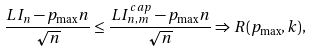<formula> <loc_0><loc_0><loc_500><loc_500>\frac { L I _ { n } - p _ { \max } n } { \sqrt { n } } & \leq \frac { L I ^ { c a p } _ { n , m } - p _ { \max } n } { \sqrt { n } } \Rightarrow R ( p _ { \max } , k ) ,</formula> 